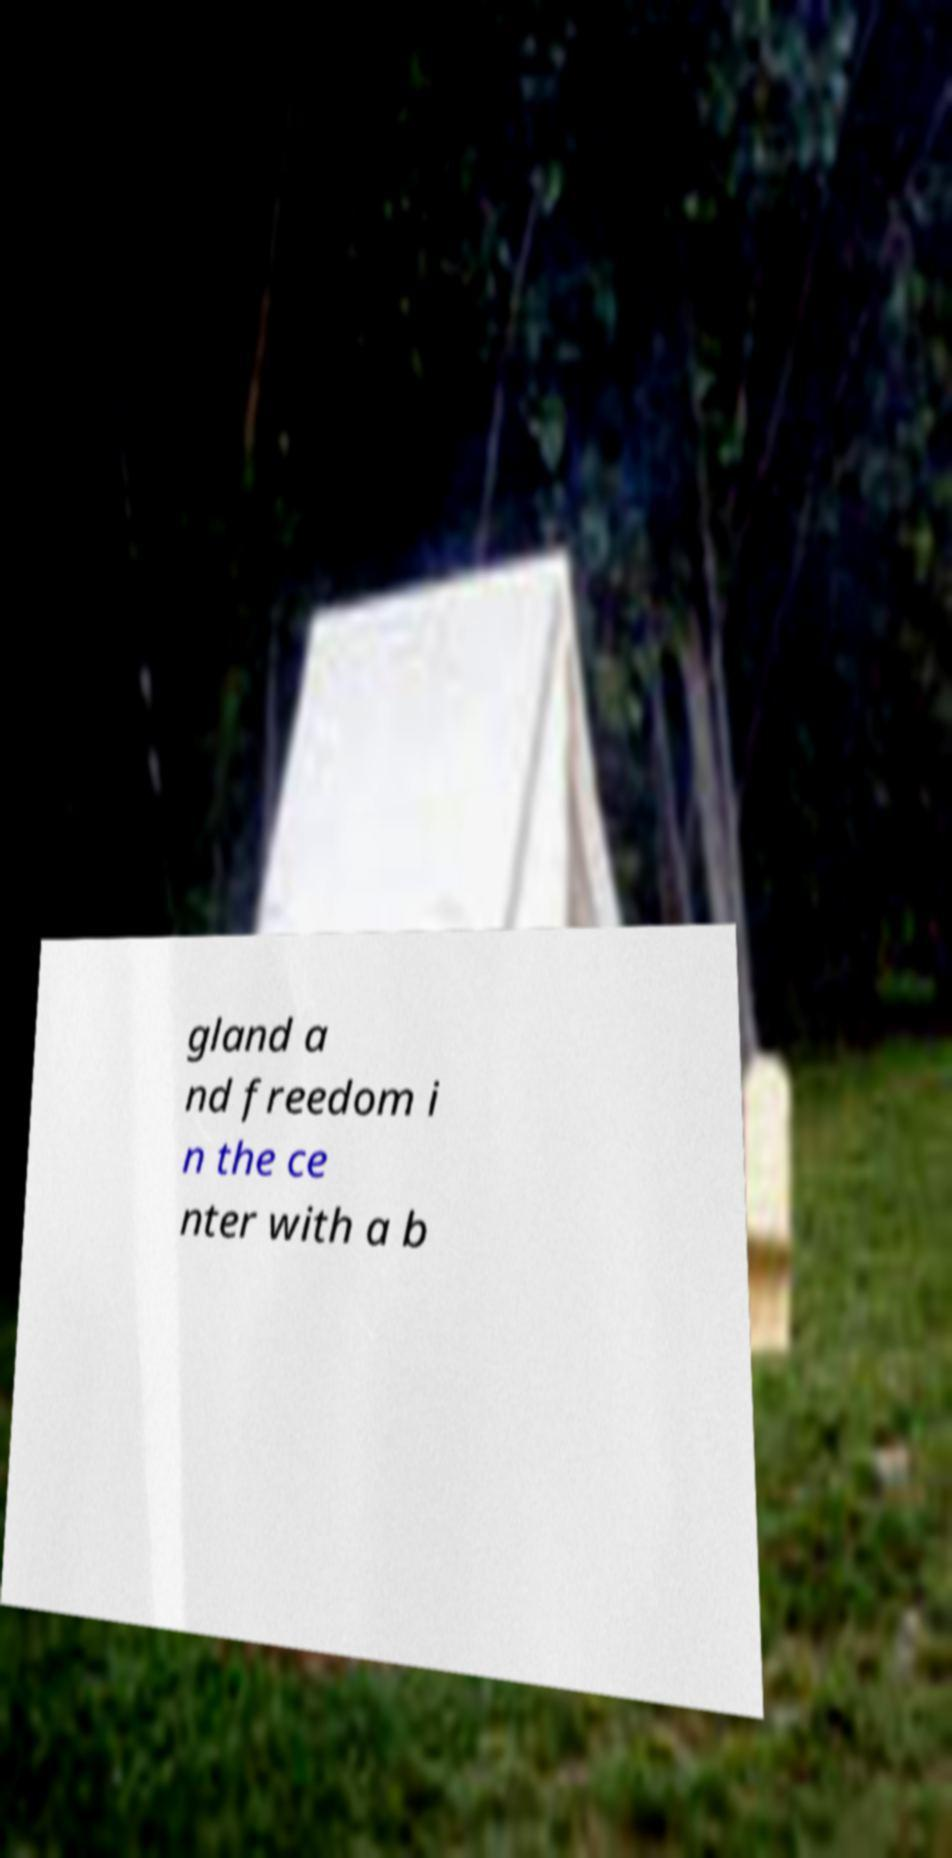There's text embedded in this image that I need extracted. Can you transcribe it verbatim? gland a nd freedom i n the ce nter with a b 